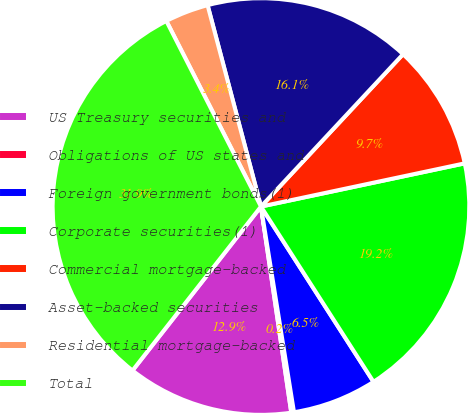Convert chart to OTSL. <chart><loc_0><loc_0><loc_500><loc_500><pie_chart><fcel>US Treasury securities and<fcel>Obligations of US states and<fcel>Foreign government bonds(1)<fcel>Corporate securities(1)<fcel>Commercial mortgage-backed<fcel>Asset-backed securities<fcel>Residential mortgage-backed<fcel>Total<nl><fcel>12.9%<fcel>0.21%<fcel>6.55%<fcel>19.24%<fcel>9.73%<fcel>16.07%<fcel>3.38%<fcel>31.92%<nl></chart> 